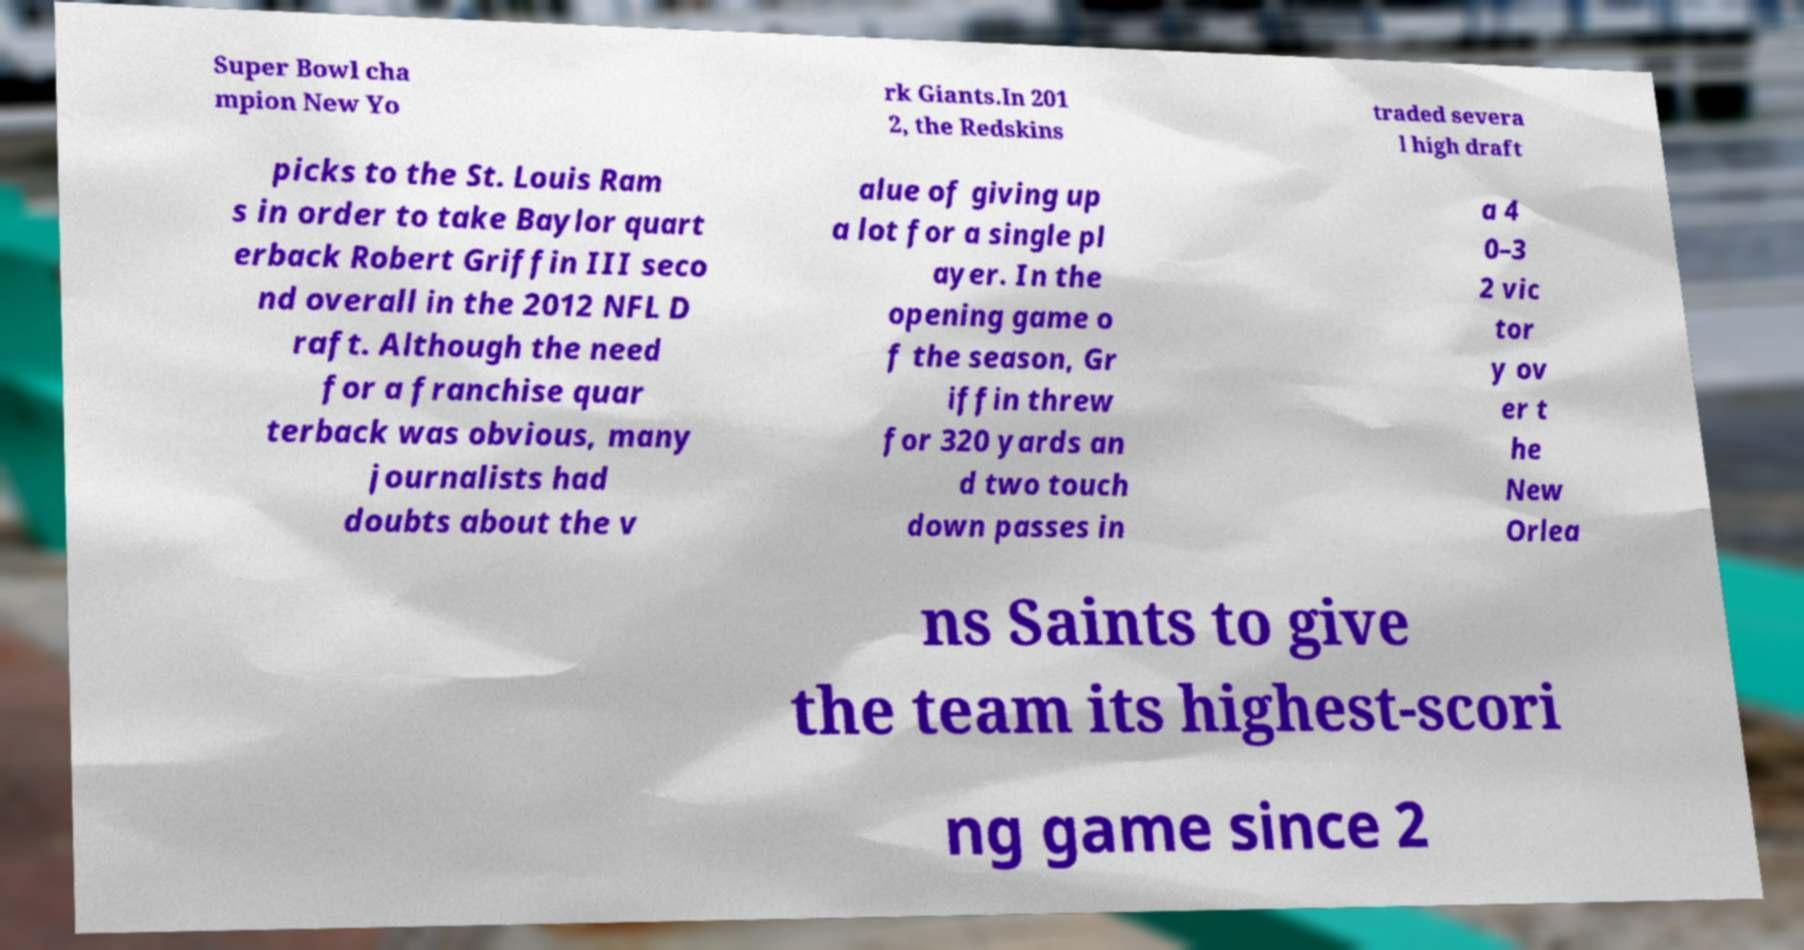Please read and relay the text visible in this image. What does it say? Super Bowl cha mpion New Yo rk Giants.In 201 2, the Redskins traded severa l high draft picks to the St. Louis Ram s in order to take Baylor quart erback Robert Griffin III seco nd overall in the 2012 NFL D raft. Although the need for a franchise quar terback was obvious, many journalists had doubts about the v alue of giving up a lot for a single pl ayer. In the opening game o f the season, Gr iffin threw for 320 yards an d two touch down passes in a 4 0–3 2 vic tor y ov er t he New Orlea ns Saints to give the team its highest-scori ng game since 2 